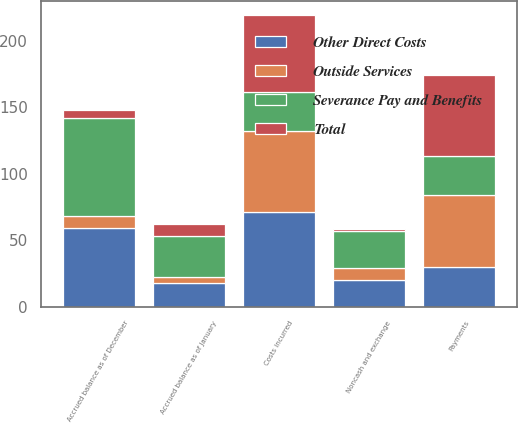<chart> <loc_0><loc_0><loc_500><loc_500><stacked_bar_chart><ecel><fcel>Accrued balance as of January<fcel>Costs incurred<fcel>Payments<fcel>Accrued balance as of December<fcel>Noncash and exchange<nl><fcel>Other Direct Costs<fcel>18<fcel>71<fcel>30<fcel>59<fcel>20<nl><fcel>Total<fcel>9<fcel>58<fcel>61<fcel>6<fcel>1<nl><fcel>Outside Services<fcel>4<fcel>61<fcel>54<fcel>9<fcel>9<nl><fcel>Severance Pay and Benefits<fcel>31<fcel>29<fcel>29<fcel>74<fcel>28<nl></chart> 